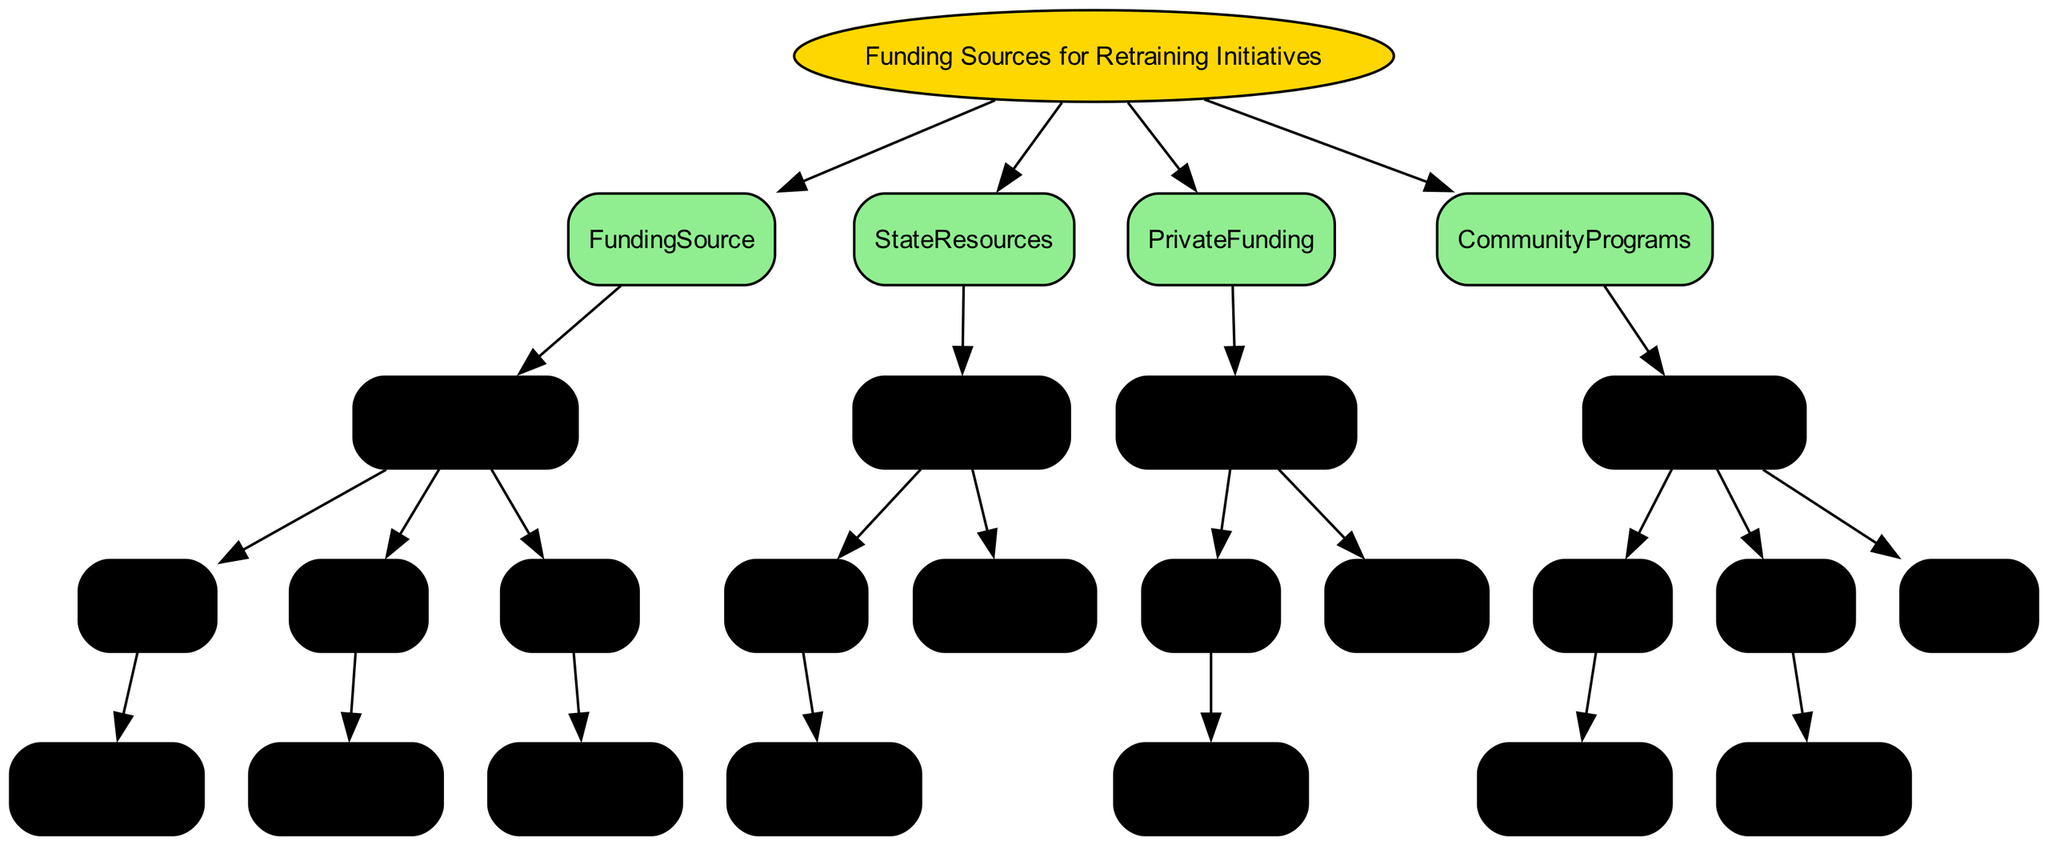What are the four main categories of funding sources for retraining initiatives? The diagram shows four main categories branching from the root: Federal Grants, State Grants, Private Funding, and Community Programs. Each category is represented as a separate node directly connected to the root.
Answer: Federal Grants, State Grants, Private Funding, Community Programs Which program is associated with the Department of Labor Employment and Training Administration? The diagram indicates that "Workforce Innovation and Opportunity Act (WIOA)" is the program linked to the "Department of Labor Employment and Training Administration." This information is found in the "High" branch under Federal Grants.
Answer: Workforce Innovation and Opportunity Act (WIOA) What type of funding is available if State Resources are labeled "NotAvailable"? The diagram shows that if State Resources are labeled "NotAvailable," then there would be no funding source detailed under that condition, indicating a lack of available funding options.
Answer: None In which category would you find "Mining Companies Partnership Program"? The "Mining Companies Partnership Program" is found under the Private Funding category. It corresponds to the "Aligned" option in the industry alignment section. This ensures that the program is aimed at businesses aligned with the mining industry.
Answer: Private Funding How many options are available under Community Programs for community need? The diagram details three options under the Community Programs for community need: High, Medium, and Low. Each option leads to different potential funding sources, reflecting varying degrees of community need.
Answer: Three What is the source detail corresponding to the Medium economic impact in Federal Grants? For a Medium economic impact under the Federal Grants category, the diagram provides details about the "U.S. Economic Development Administration" and its "Economic Adjustment Assistance Program." This information helps identify a specific source available for that impact level.
Answer: U.S. Economic Development Administration, Economic Adjustment Assistance Program If a state grant is available, which organization is responsible for it? The diagram cites the "State Workforce Development Boards" as the organization responsible for state grants when they are available, indicating the managing body for state funding in retraining initiatives.
Answer: State Workforce Development Boards What is the program associated with Local Community Colleges under Community Programs? The diagram shows that local community colleges are linked to "Workforce Training Programs." This indicates that they provide training initiatives in response to community needs addressed in the program’s options.
Answer: Workforce Training Programs 